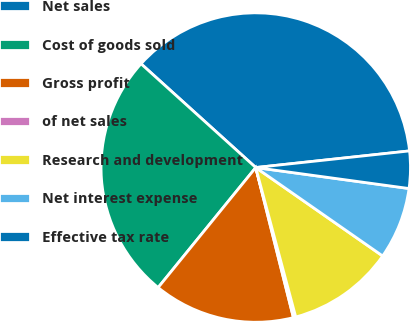Convert chart. <chart><loc_0><loc_0><loc_500><loc_500><pie_chart><fcel>Net sales<fcel>Cost of goods sold<fcel>Gross profit<fcel>of net sales<fcel>Research and development<fcel>Net interest expense<fcel>Effective tax rate<nl><fcel>36.58%<fcel>25.83%<fcel>14.78%<fcel>0.25%<fcel>11.15%<fcel>7.52%<fcel>3.88%<nl></chart> 